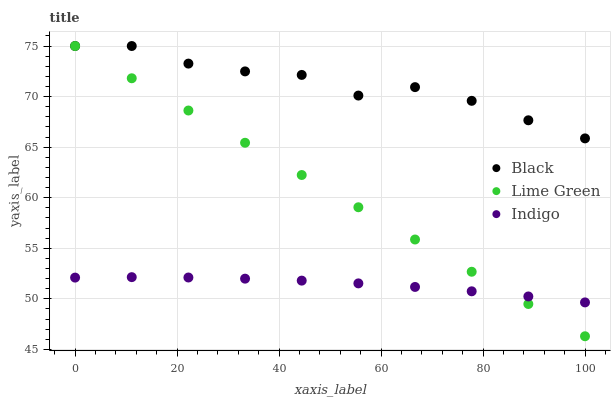Does Indigo have the minimum area under the curve?
Answer yes or no. Yes. Does Black have the maximum area under the curve?
Answer yes or no. Yes. Does Black have the minimum area under the curve?
Answer yes or no. No. Does Indigo have the maximum area under the curve?
Answer yes or no. No. Is Lime Green the smoothest?
Answer yes or no. Yes. Is Black the roughest?
Answer yes or no. Yes. Is Indigo the smoothest?
Answer yes or no. No. Is Indigo the roughest?
Answer yes or no. No. Does Lime Green have the lowest value?
Answer yes or no. Yes. Does Indigo have the lowest value?
Answer yes or no. No. Does Black have the highest value?
Answer yes or no. Yes. Does Indigo have the highest value?
Answer yes or no. No. Is Indigo less than Black?
Answer yes or no. Yes. Is Black greater than Indigo?
Answer yes or no. Yes. Does Indigo intersect Lime Green?
Answer yes or no. Yes. Is Indigo less than Lime Green?
Answer yes or no. No. Is Indigo greater than Lime Green?
Answer yes or no. No. Does Indigo intersect Black?
Answer yes or no. No. 